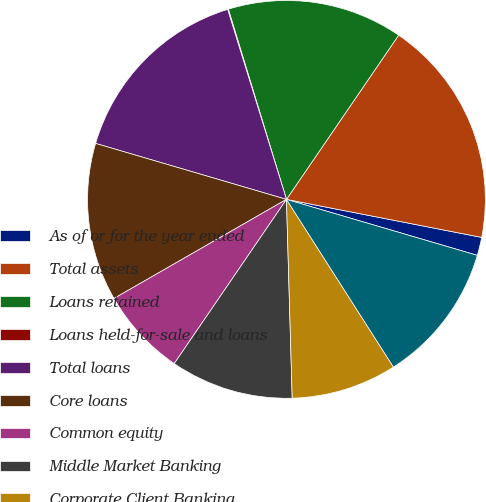<chart> <loc_0><loc_0><loc_500><loc_500><pie_chart><fcel>As of or for the year ended<fcel>Total assets<fcel>Loans retained<fcel>Loans held-for-sale and loans<fcel>Total loans<fcel>Core loans<fcel>Common equity<fcel>Middle Market Banking<fcel>Corporate Client Banking<fcel>Commercial Term Lending<nl><fcel>1.48%<fcel>18.52%<fcel>14.26%<fcel>0.06%<fcel>15.68%<fcel>12.84%<fcel>7.16%<fcel>10.0%<fcel>8.58%<fcel>11.42%<nl></chart> 